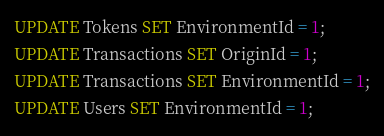<code> <loc_0><loc_0><loc_500><loc_500><_SQL_>UPDATE Tokens SET EnvironmentId = 1;
UPDATE Transactions SET OriginId = 1;
UPDATE Transactions SET EnvironmentId = 1;
UPDATE Users SET EnvironmentId = 1;</code> 